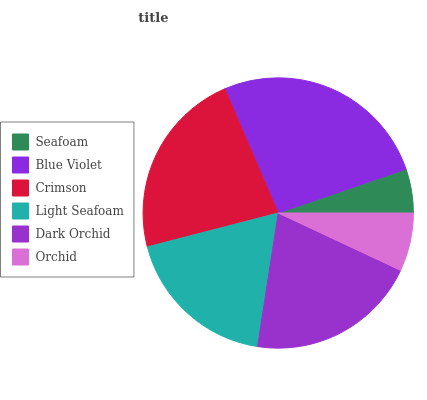Is Seafoam the minimum?
Answer yes or no. Yes. Is Blue Violet the maximum?
Answer yes or no. Yes. Is Crimson the minimum?
Answer yes or no. No. Is Crimson the maximum?
Answer yes or no. No. Is Blue Violet greater than Crimson?
Answer yes or no. Yes. Is Crimson less than Blue Violet?
Answer yes or no. Yes. Is Crimson greater than Blue Violet?
Answer yes or no. No. Is Blue Violet less than Crimson?
Answer yes or no. No. Is Dark Orchid the high median?
Answer yes or no. Yes. Is Light Seafoam the low median?
Answer yes or no. Yes. Is Seafoam the high median?
Answer yes or no. No. Is Blue Violet the low median?
Answer yes or no. No. 